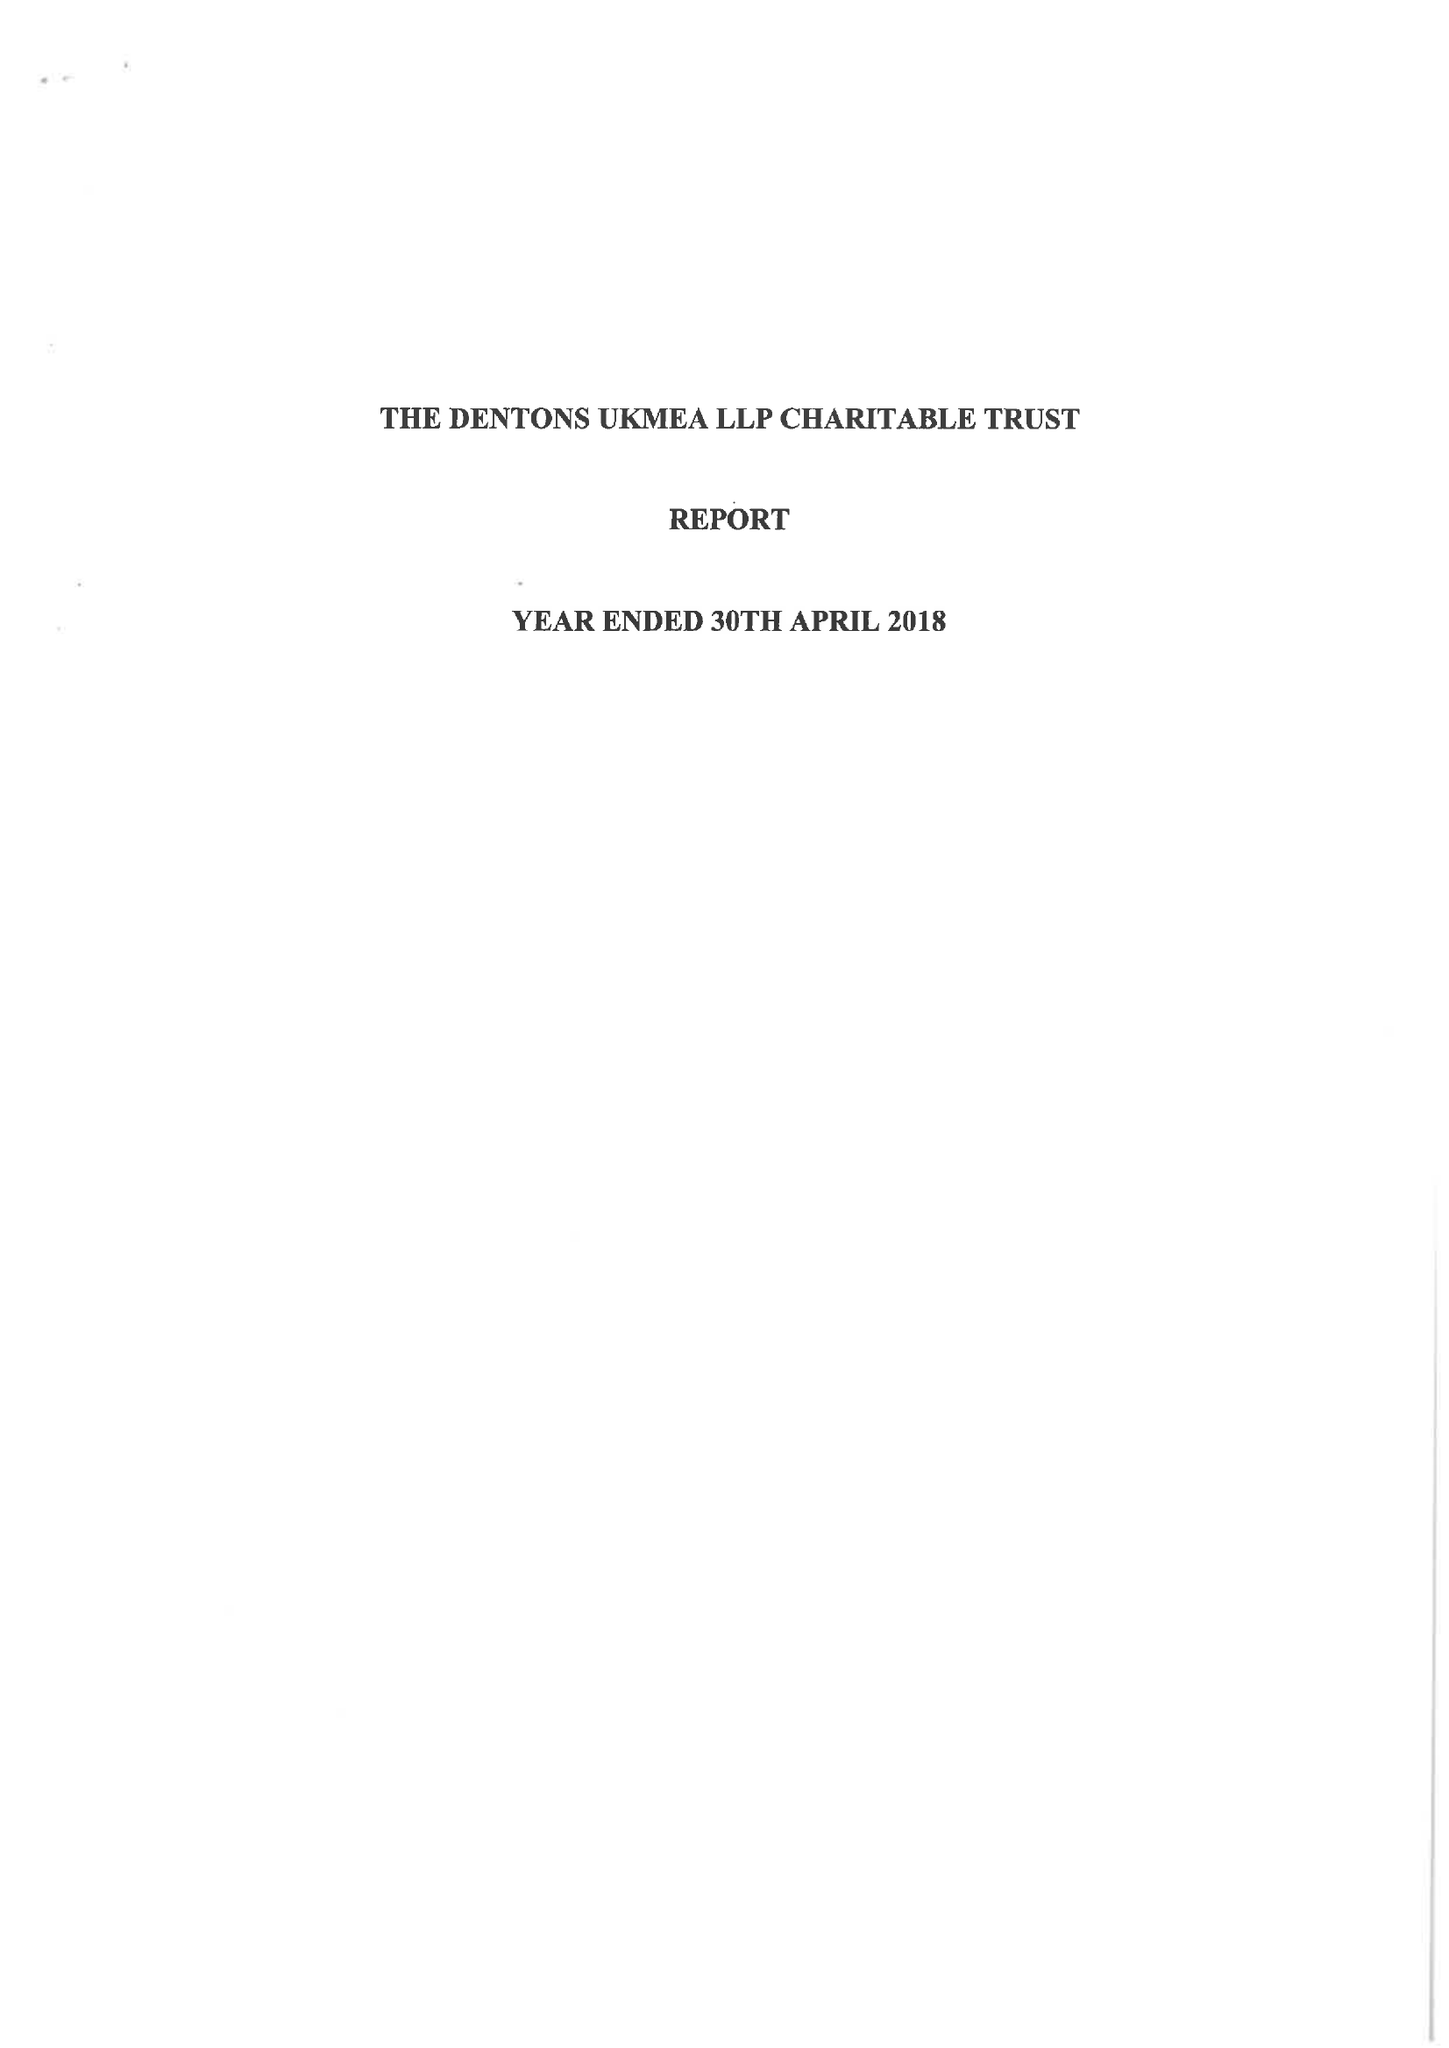What is the value for the report_date?
Answer the question using a single word or phrase. 2018-04-30 